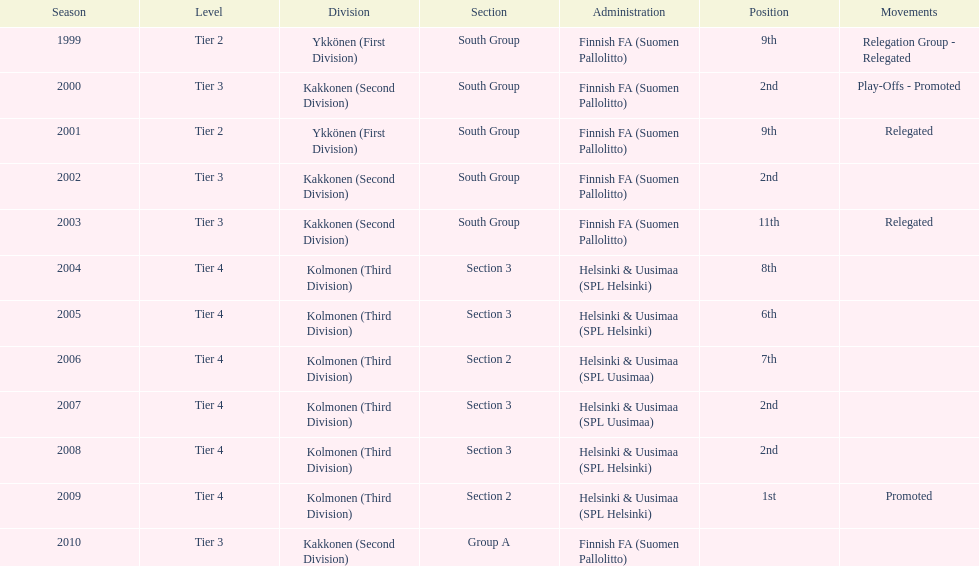Which administration has the least amount of division? Helsinki & Uusimaa (SPL Helsinki). 